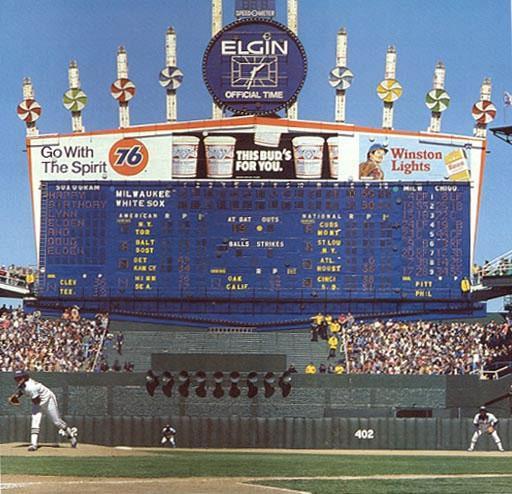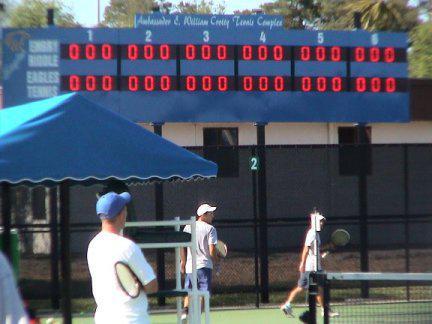The first image is the image on the left, the second image is the image on the right. Given the left and right images, does the statement "The sport being played in the left image was invented in the United States." hold true? Answer yes or no. Yes. 